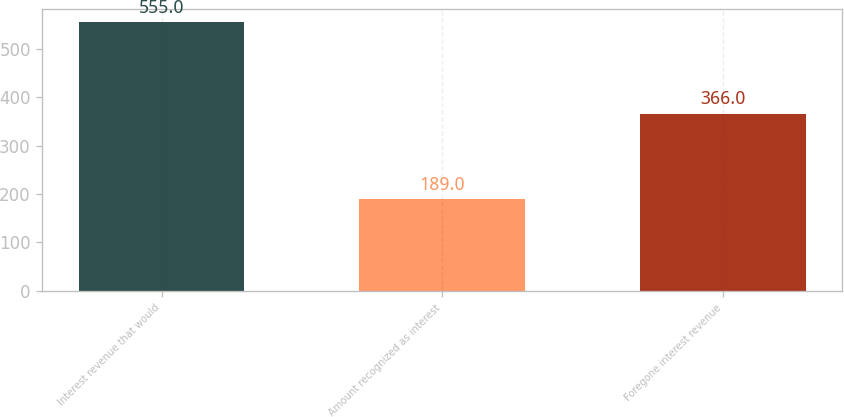Convert chart to OTSL. <chart><loc_0><loc_0><loc_500><loc_500><bar_chart><fcel>Interest revenue that would<fcel>Amount recognized as interest<fcel>Foregone interest revenue<nl><fcel>555<fcel>189<fcel>366<nl></chart> 